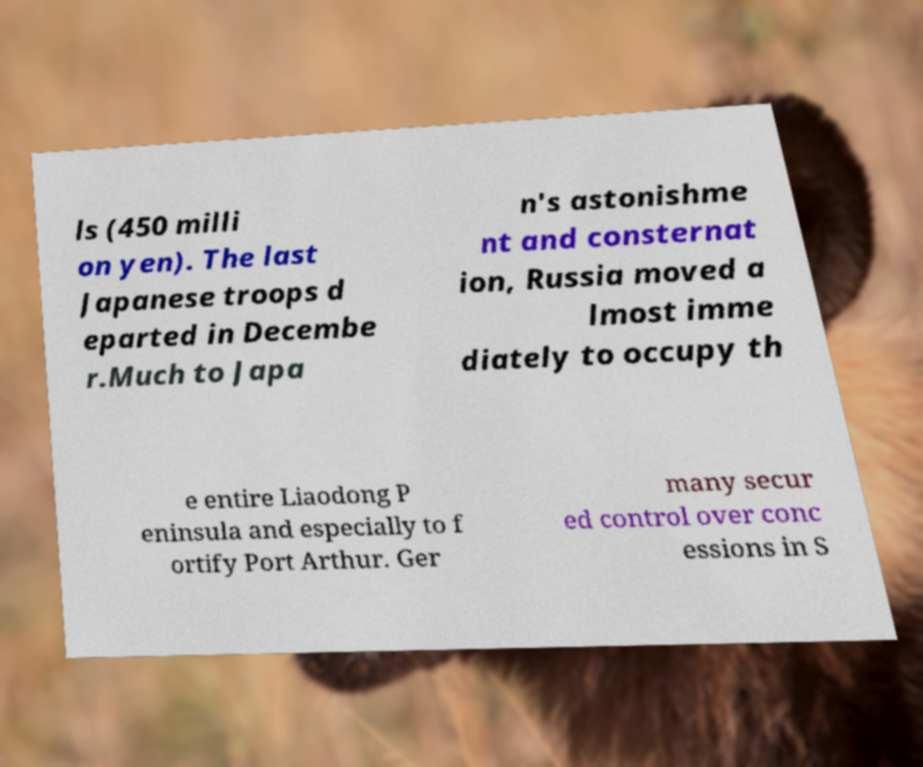Can you read and provide the text displayed in the image?This photo seems to have some interesting text. Can you extract and type it out for me? ls (450 milli on yen). The last Japanese troops d eparted in Decembe r.Much to Japa n's astonishme nt and consternat ion, Russia moved a lmost imme diately to occupy th e entire Liaodong P eninsula and especially to f ortify Port Arthur. Ger many secur ed control over conc essions in S 